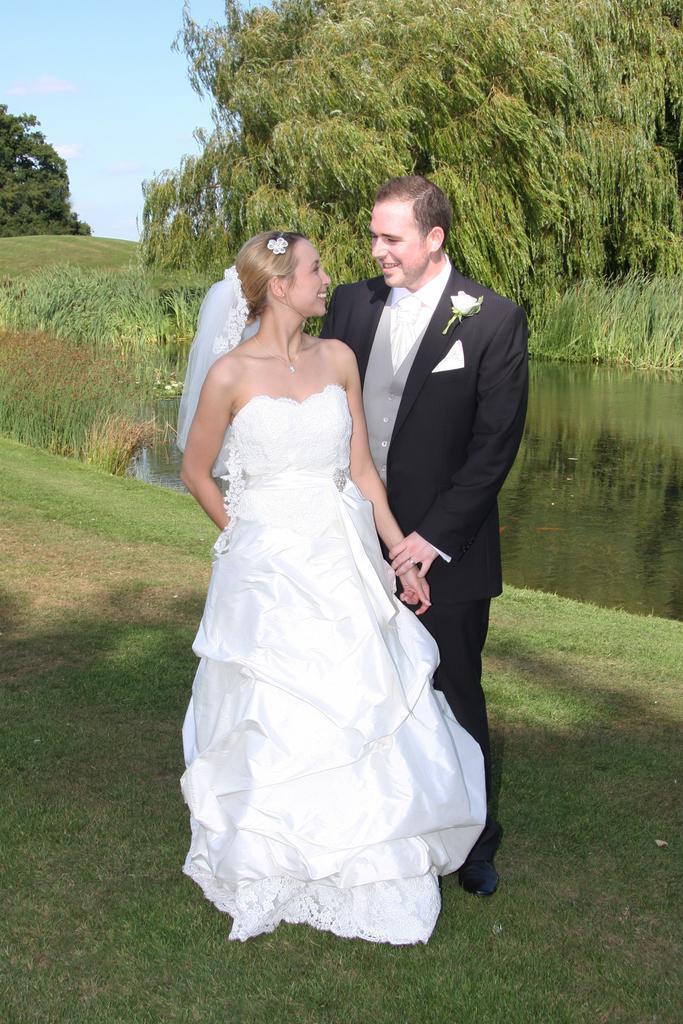Can you describe this image briefly? In the center of the image there are two persons standing. At the bottom of the image there is grass. There is water. In the background of the image there are trees. 